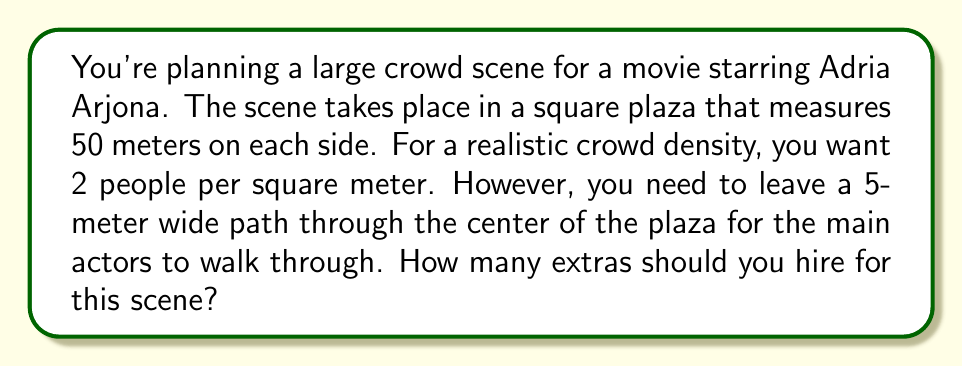Solve this math problem. Let's approach this step-by-step:

1) First, calculate the total area of the plaza:
   $A_{total} = 50m \times 50m = 2500m^2$

2) Now, calculate the area of the path that needs to be left clear:
   $A_{path} = 50m \times 5m = 250m^2$

3) The area available for extras is the difference:
   $A_{extras} = A_{total} - A_{path} = 2500m^2 - 250m^2 = 2250m^2$

4) Given the desired density of 2 people per square meter, we can calculate the number of extras:
   $N_{extras} = A_{extras} \times 2\text{ people}/m^2$
   $N_{extras} = 2250m^2 \times 2\text{ people}/m^2 = 4500\text{ people}$

5) However, we need to round this to a whole number, as we can't hire fractional people. In this case, rounding down to ensure we don't exceed the available space:

   $N_{extras} = \lfloor 4500 \rfloor = 4500$

Therefore, you should hire 4500 extras for this crowd scene.
Answer: 4500 extras 